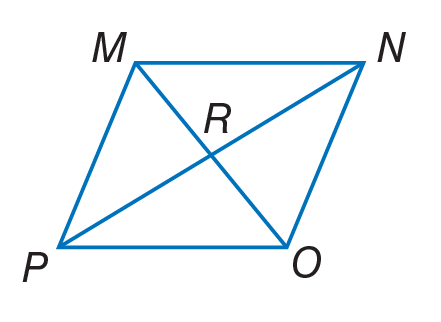Question: Quadrilateral M N O P is a rhombus. If P R = 12, find R N.
Choices:
A. 6
B. 12
C. 20
D. 24
Answer with the letter. Answer: B Question: Quadrilateral M N O P is a rhombus. Find m \angle M R N.
Choices:
A. 56
B. 90
C. 124
D. 140
Answer with the letter. Answer: B Question: Quadrilateral M N O P is a rhombus. If m \angle P O N = 124, find m \angle P O M.
Choices:
A. 12
B. 56
C. 62
D. 124
Answer with the letter. Answer: C 